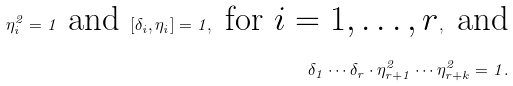<formula> <loc_0><loc_0><loc_500><loc_500>\eta _ { i } ^ { 2 } = 1 \text { and } [ \delta _ { i } , \eta _ { i } ] = 1 , \text { for  $i=1,\dots,r$} , \text { and} \\ \delta _ { 1 } \cdots \delta _ { r } \cdot \eta _ { r + 1 } ^ { 2 } \cdots \eta _ { r + k } ^ { 2 } = 1 .</formula> 